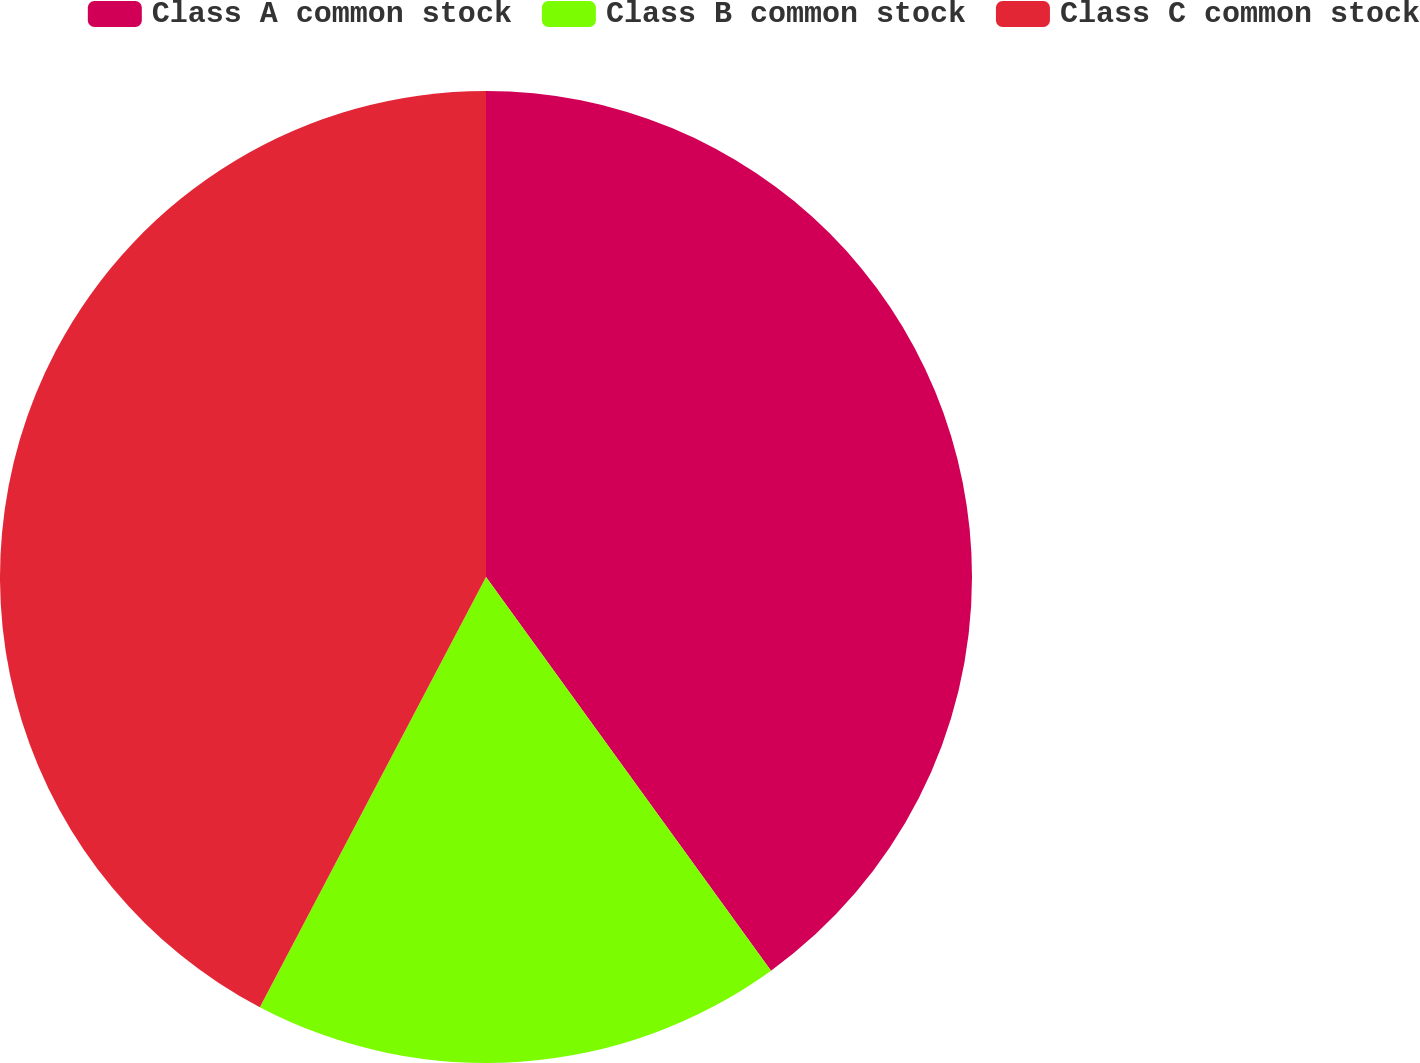<chart> <loc_0><loc_0><loc_500><loc_500><pie_chart><fcel>Class A common stock<fcel>Class B common stock<fcel>Class C common stock<nl><fcel>40.03%<fcel>17.68%<fcel>42.3%<nl></chart> 